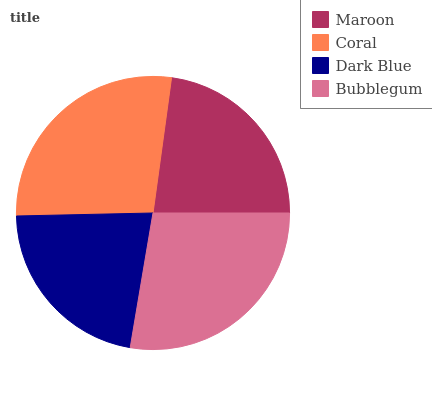Is Dark Blue the minimum?
Answer yes or no. Yes. Is Bubblegum the maximum?
Answer yes or no. Yes. Is Coral the minimum?
Answer yes or no. No. Is Coral the maximum?
Answer yes or no. No. Is Coral greater than Maroon?
Answer yes or no. Yes. Is Maroon less than Coral?
Answer yes or no. Yes. Is Maroon greater than Coral?
Answer yes or no. No. Is Coral less than Maroon?
Answer yes or no. No. Is Coral the high median?
Answer yes or no. Yes. Is Maroon the low median?
Answer yes or no. Yes. Is Maroon the high median?
Answer yes or no. No. Is Dark Blue the low median?
Answer yes or no. No. 